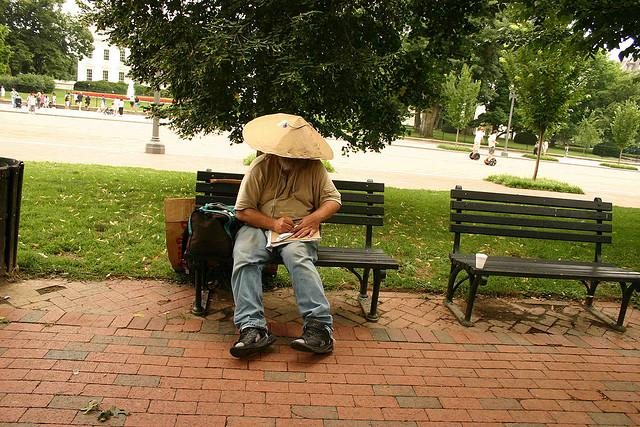What purpose does the large disk on this person's head serve most here? shade 